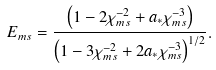Convert formula to latex. <formula><loc_0><loc_0><loc_500><loc_500>E _ { m s } = \frac { \left ( { 1 - 2 \chi _ { m s } ^ { - 2 } + a _ { * } \chi _ { m s } ^ { - 3 } } \right ) } { \left ( { 1 - 3 \chi _ { m s } ^ { - 2 } + 2 a _ { * } \chi _ { m s } ^ { - 3 } } \right ) ^ { 1 / 2 } } .</formula> 